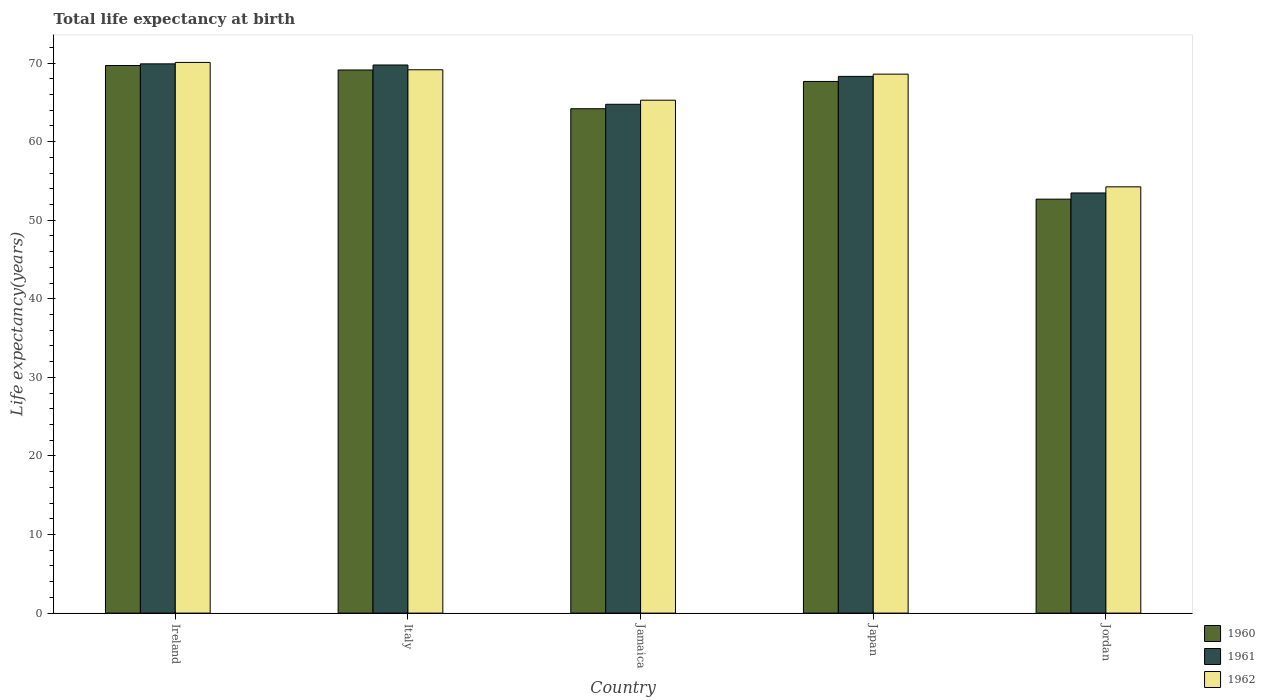How many bars are there on the 2nd tick from the left?
Your answer should be compact. 3. What is the label of the 3rd group of bars from the left?
Make the answer very short. Jamaica. In how many cases, is the number of bars for a given country not equal to the number of legend labels?
Your response must be concise. 0. What is the life expectancy at birth in in 1962 in Ireland?
Provide a succinct answer. 70.09. Across all countries, what is the maximum life expectancy at birth in in 1962?
Your response must be concise. 70.09. Across all countries, what is the minimum life expectancy at birth in in 1961?
Your answer should be compact. 53.47. In which country was the life expectancy at birth in in 1962 maximum?
Provide a short and direct response. Ireland. In which country was the life expectancy at birth in in 1961 minimum?
Provide a succinct answer. Jordan. What is the total life expectancy at birth in in 1960 in the graph?
Make the answer very short. 323.36. What is the difference between the life expectancy at birth in in 1960 in Ireland and that in Jordan?
Your answer should be compact. 17.01. What is the difference between the life expectancy at birth in in 1962 in Japan and the life expectancy at birth in in 1960 in Italy?
Ensure brevity in your answer.  -0.53. What is the average life expectancy at birth in in 1960 per country?
Provide a succinct answer. 64.67. What is the difference between the life expectancy at birth in of/in 1961 and life expectancy at birth in of/in 1960 in Jamaica?
Your answer should be compact. 0.57. In how many countries, is the life expectancy at birth in in 1961 greater than 62 years?
Offer a terse response. 4. What is the ratio of the life expectancy at birth in in 1962 in Jamaica to that in Jordan?
Your answer should be very brief. 1.2. Is the difference between the life expectancy at birth in in 1961 in Ireland and Japan greater than the difference between the life expectancy at birth in in 1960 in Ireland and Japan?
Offer a terse response. No. What is the difference between the highest and the second highest life expectancy at birth in in 1961?
Give a very brief answer. -0.14. What is the difference between the highest and the lowest life expectancy at birth in in 1960?
Offer a terse response. 17.01. In how many countries, is the life expectancy at birth in in 1962 greater than the average life expectancy at birth in in 1962 taken over all countries?
Offer a very short reply. 3. What does the 3rd bar from the right in Jamaica represents?
Ensure brevity in your answer.  1960. Are all the bars in the graph horizontal?
Keep it short and to the point. No. What is the difference between two consecutive major ticks on the Y-axis?
Provide a succinct answer. 10. Where does the legend appear in the graph?
Your answer should be very brief. Bottom right. How many legend labels are there?
Provide a short and direct response. 3. What is the title of the graph?
Make the answer very short. Total life expectancy at birth. What is the label or title of the X-axis?
Ensure brevity in your answer.  Country. What is the label or title of the Y-axis?
Provide a succinct answer. Life expectancy(years). What is the Life expectancy(years) of 1960 in Ireland?
Make the answer very short. 69.69. What is the Life expectancy(years) of 1961 in Ireland?
Your answer should be very brief. 69.9. What is the Life expectancy(years) of 1962 in Ireland?
Offer a terse response. 70.09. What is the Life expectancy(years) of 1960 in Italy?
Make the answer very short. 69.12. What is the Life expectancy(years) in 1961 in Italy?
Provide a short and direct response. 69.76. What is the Life expectancy(years) in 1962 in Italy?
Make the answer very short. 69.15. What is the Life expectancy(years) of 1960 in Jamaica?
Your response must be concise. 64.19. What is the Life expectancy(years) of 1961 in Jamaica?
Your answer should be very brief. 64.76. What is the Life expectancy(years) of 1962 in Jamaica?
Ensure brevity in your answer.  65.28. What is the Life expectancy(years) of 1960 in Japan?
Provide a short and direct response. 67.67. What is the Life expectancy(years) in 1961 in Japan?
Offer a very short reply. 68.31. What is the Life expectancy(years) of 1962 in Japan?
Your answer should be compact. 68.59. What is the Life expectancy(years) in 1960 in Jordan?
Provide a succinct answer. 52.69. What is the Life expectancy(years) in 1961 in Jordan?
Your answer should be very brief. 53.47. What is the Life expectancy(years) of 1962 in Jordan?
Your answer should be compact. 54.25. Across all countries, what is the maximum Life expectancy(years) in 1960?
Keep it short and to the point. 69.69. Across all countries, what is the maximum Life expectancy(years) in 1961?
Offer a very short reply. 69.9. Across all countries, what is the maximum Life expectancy(years) of 1962?
Keep it short and to the point. 70.09. Across all countries, what is the minimum Life expectancy(years) in 1960?
Give a very brief answer. 52.69. Across all countries, what is the minimum Life expectancy(years) of 1961?
Your answer should be compact. 53.47. Across all countries, what is the minimum Life expectancy(years) of 1962?
Make the answer very short. 54.25. What is the total Life expectancy(years) in 1960 in the graph?
Offer a terse response. 323.36. What is the total Life expectancy(years) in 1961 in the graph?
Provide a short and direct response. 326.21. What is the total Life expectancy(years) in 1962 in the graph?
Your answer should be compact. 327.36. What is the difference between the Life expectancy(years) in 1960 in Ireland and that in Italy?
Provide a succinct answer. 0.57. What is the difference between the Life expectancy(years) in 1961 in Ireland and that in Italy?
Your answer should be very brief. 0.14. What is the difference between the Life expectancy(years) of 1962 in Ireland and that in Italy?
Ensure brevity in your answer.  0.94. What is the difference between the Life expectancy(years) of 1960 in Ireland and that in Jamaica?
Your answer should be compact. 5.5. What is the difference between the Life expectancy(years) in 1961 in Ireland and that in Jamaica?
Make the answer very short. 5.14. What is the difference between the Life expectancy(years) in 1962 in Ireland and that in Jamaica?
Your response must be concise. 4.81. What is the difference between the Life expectancy(years) of 1960 in Ireland and that in Japan?
Provide a succinct answer. 2.03. What is the difference between the Life expectancy(years) of 1961 in Ireland and that in Japan?
Offer a very short reply. 1.59. What is the difference between the Life expectancy(years) of 1962 in Ireland and that in Japan?
Keep it short and to the point. 1.49. What is the difference between the Life expectancy(years) of 1960 in Ireland and that in Jordan?
Your response must be concise. 17.01. What is the difference between the Life expectancy(years) of 1961 in Ireland and that in Jordan?
Your answer should be compact. 16.43. What is the difference between the Life expectancy(years) of 1962 in Ireland and that in Jordan?
Offer a very short reply. 15.84. What is the difference between the Life expectancy(years) of 1960 in Italy and that in Jamaica?
Keep it short and to the point. 4.93. What is the difference between the Life expectancy(years) in 1961 in Italy and that in Jamaica?
Provide a short and direct response. 5. What is the difference between the Life expectancy(years) in 1962 in Italy and that in Jamaica?
Keep it short and to the point. 3.87. What is the difference between the Life expectancy(years) of 1960 in Italy and that in Japan?
Offer a terse response. 1.46. What is the difference between the Life expectancy(years) of 1961 in Italy and that in Japan?
Offer a terse response. 1.45. What is the difference between the Life expectancy(years) of 1962 in Italy and that in Japan?
Your response must be concise. 0.55. What is the difference between the Life expectancy(years) in 1960 in Italy and that in Jordan?
Keep it short and to the point. 16.44. What is the difference between the Life expectancy(years) in 1961 in Italy and that in Jordan?
Ensure brevity in your answer.  16.29. What is the difference between the Life expectancy(years) in 1962 in Italy and that in Jordan?
Your response must be concise. 14.9. What is the difference between the Life expectancy(years) in 1960 in Jamaica and that in Japan?
Offer a terse response. -3.47. What is the difference between the Life expectancy(years) in 1961 in Jamaica and that in Japan?
Ensure brevity in your answer.  -3.55. What is the difference between the Life expectancy(years) of 1962 in Jamaica and that in Japan?
Offer a very short reply. -3.32. What is the difference between the Life expectancy(years) of 1960 in Jamaica and that in Jordan?
Your answer should be very brief. 11.51. What is the difference between the Life expectancy(years) of 1961 in Jamaica and that in Jordan?
Keep it short and to the point. 11.29. What is the difference between the Life expectancy(years) of 1962 in Jamaica and that in Jordan?
Give a very brief answer. 11.03. What is the difference between the Life expectancy(years) of 1960 in Japan and that in Jordan?
Provide a short and direct response. 14.98. What is the difference between the Life expectancy(years) of 1961 in Japan and that in Jordan?
Provide a succinct answer. 14.84. What is the difference between the Life expectancy(years) of 1962 in Japan and that in Jordan?
Offer a terse response. 14.34. What is the difference between the Life expectancy(years) in 1960 in Ireland and the Life expectancy(years) in 1961 in Italy?
Make the answer very short. -0.07. What is the difference between the Life expectancy(years) of 1960 in Ireland and the Life expectancy(years) of 1962 in Italy?
Your response must be concise. 0.54. What is the difference between the Life expectancy(years) in 1961 in Ireland and the Life expectancy(years) in 1962 in Italy?
Give a very brief answer. 0.75. What is the difference between the Life expectancy(years) in 1960 in Ireland and the Life expectancy(years) in 1961 in Jamaica?
Provide a succinct answer. 4.93. What is the difference between the Life expectancy(years) in 1960 in Ireland and the Life expectancy(years) in 1962 in Jamaica?
Your answer should be very brief. 4.41. What is the difference between the Life expectancy(years) in 1961 in Ireland and the Life expectancy(years) in 1962 in Jamaica?
Provide a short and direct response. 4.62. What is the difference between the Life expectancy(years) in 1960 in Ireland and the Life expectancy(years) in 1961 in Japan?
Offer a terse response. 1.38. What is the difference between the Life expectancy(years) of 1960 in Ireland and the Life expectancy(years) of 1962 in Japan?
Provide a short and direct response. 1.1. What is the difference between the Life expectancy(years) in 1961 in Ireland and the Life expectancy(years) in 1962 in Japan?
Provide a short and direct response. 1.31. What is the difference between the Life expectancy(years) of 1960 in Ireland and the Life expectancy(years) of 1961 in Jordan?
Provide a succinct answer. 16.22. What is the difference between the Life expectancy(years) of 1960 in Ireland and the Life expectancy(years) of 1962 in Jordan?
Your answer should be compact. 15.44. What is the difference between the Life expectancy(years) of 1961 in Ireland and the Life expectancy(years) of 1962 in Jordan?
Provide a succinct answer. 15.65. What is the difference between the Life expectancy(years) of 1960 in Italy and the Life expectancy(years) of 1961 in Jamaica?
Offer a very short reply. 4.36. What is the difference between the Life expectancy(years) in 1960 in Italy and the Life expectancy(years) in 1962 in Jamaica?
Your answer should be compact. 3.84. What is the difference between the Life expectancy(years) of 1961 in Italy and the Life expectancy(years) of 1962 in Jamaica?
Give a very brief answer. 4.48. What is the difference between the Life expectancy(years) in 1960 in Italy and the Life expectancy(years) in 1961 in Japan?
Offer a very short reply. 0.81. What is the difference between the Life expectancy(years) in 1960 in Italy and the Life expectancy(years) in 1962 in Japan?
Offer a very short reply. 0.53. What is the difference between the Life expectancy(years) in 1961 in Italy and the Life expectancy(years) in 1962 in Japan?
Offer a very short reply. 1.17. What is the difference between the Life expectancy(years) in 1960 in Italy and the Life expectancy(years) in 1961 in Jordan?
Offer a very short reply. 15.65. What is the difference between the Life expectancy(years) in 1960 in Italy and the Life expectancy(years) in 1962 in Jordan?
Your response must be concise. 14.87. What is the difference between the Life expectancy(years) of 1961 in Italy and the Life expectancy(years) of 1962 in Jordan?
Provide a succinct answer. 15.51. What is the difference between the Life expectancy(years) of 1960 in Jamaica and the Life expectancy(years) of 1961 in Japan?
Make the answer very short. -4.12. What is the difference between the Life expectancy(years) in 1960 in Jamaica and the Life expectancy(years) in 1962 in Japan?
Your answer should be very brief. -4.4. What is the difference between the Life expectancy(years) in 1961 in Jamaica and the Life expectancy(years) in 1962 in Japan?
Your response must be concise. -3.84. What is the difference between the Life expectancy(years) of 1960 in Jamaica and the Life expectancy(years) of 1961 in Jordan?
Provide a short and direct response. 10.72. What is the difference between the Life expectancy(years) in 1960 in Jamaica and the Life expectancy(years) in 1962 in Jordan?
Provide a succinct answer. 9.94. What is the difference between the Life expectancy(years) in 1961 in Jamaica and the Life expectancy(years) in 1962 in Jordan?
Offer a terse response. 10.51. What is the difference between the Life expectancy(years) in 1960 in Japan and the Life expectancy(years) in 1961 in Jordan?
Your answer should be very brief. 14.19. What is the difference between the Life expectancy(years) of 1960 in Japan and the Life expectancy(years) of 1962 in Jordan?
Give a very brief answer. 13.41. What is the difference between the Life expectancy(years) in 1961 in Japan and the Life expectancy(years) in 1962 in Jordan?
Offer a terse response. 14.06. What is the average Life expectancy(years) in 1960 per country?
Provide a succinct answer. 64.67. What is the average Life expectancy(years) of 1961 per country?
Offer a very short reply. 65.24. What is the average Life expectancy(years) of 1962 per country?
Keep it short and to the point. 65.47. What is the difference between the Life expectancy(years) in 1960 and Life expectancy(years) in 1961 in Ireland?
Provide a short and direct response. -0.21. What is the difference between the Life expectancy(years) in 1960 and Life expectancy(years) in 1962 in Ireland?
Your response must be concise. -0.4. What is the difference between the Life expectancy(years) in 1961 and Life expectancy(years) in 1962 in Ireland?
Keep it short and to the point. -0.18. What is the difference between the Life expectancy(years) in 1960 and Life expectancy(years) in 1961 in Italy?
Offer a very short reply. -0.64. What is the difference between the Life expectancy(years) of 1960 and Life expectancy(years) of 1962 in Italy?
Provide a succinct answer. -0.03. What is the difference between the Life expectancy(years) in 1961 and Life expectancy(years) in 1962 in Italy?
Offer a terse response. 0.61. What is the difference between the Life expectancy(years) in 1960 and Life expectancy(years) in 1961 in Jamaica?
Your response must be concise. -0.57. What is the difference between the Life expectancy(years) of 1960 and Life expectancy(years) of 1962 in Jamaica?
Your answer should be compact. -1.09. What is the difference between the Life expectancy(years) of 1961 and Life expectancy(years) of 1962 in Jamaica?
Your answer should be compact. -0.52. What is the difference between the Life expectancy(years) of 1960 and Life expectancy(years) of 1961 in Japan?
Make the answer very short. -0.64. What is the difference between the Life expectancy(years) of 1960 and Life expectancy(years) of 1962 in Japan?
Your answer should be very brief. -0.93. What is the difference between the Life expectancy(years) in 1961 and Life expectancy(years) in 1962 in Japan?
Give a very brief answer. -0.28. What is the difference between the Life expectancy(years) of 1960 and Life expectancy(years) of 1961 in Jordan?
Offer a terse response. -0.79. What is the difference between the Life expectancy(years) in 1960 and Life expectancy(years) in 1962 in Jordan?
Make the answer very short. -1.57. What is the difference between the Life expectancy(years) in 1961 and Life expectancy(years) in 1962 in Jordan?
Give a very brief answer. -0.78. What is the ratio of the Life expectancy(years) of 1960 in Ireland to that in Italy?
Your answer should be very brief. 1.01. What is the ratio of the Life expectancy(years) of 1962 in Ireland to that in Italy?
Your response must be concise. 1.01. What is the ratio of the Life expectancy(years) of 1960 in Ireland to that in Jamaica?
Keep it short and to the point. 1.09. What is the ratio of the Life expectancy(years) of 1961 in Ireland to that in Jamaica?
Provide a succinct answer. 1.08. What is the ratio of the Life expectancy(years) of 1962 in Ireland to that in Jamaica?
Offer a terse response. 1.07. What is the ratio of the Life expectancy(years) in 1960 in Ireland to that in Japan?
Provide a succinct answer. 1.03. What is the ratio of the Life expectancy(years) of 1961 in Ireland to that in Japan?
Offer a terse response. 1.02. What is the ratio of the Life expectancy(years) of 1962 in Ireland to that in Japan?
Offer a very short reply. 1.02. What is the ratio of the Life expectancy(years) in 1960 in Ireland to that in Jordan?
Make the answer very short. 1.32. What is the ratio of the Life expectancy(years) in 1961 in Ireland to that in Jordan?
Make the answer very short. 1.31. What is the ratio of the Life expectancy(years) of 1962 in Ireland to that in Jordan?
Offer a very short reply. 1.29. What is the ratio of the Life expectancy(years) in 1960 in Italy to that in Jamaica?
Provide a succinct answer. 1.08. What is the ratio of the Life expectancy(years) in 1961 in Italy to that in Jamaica?
Provide a short and direct response. 1.08. What is the ratio of the Life expectancy(years) in 1962 in Italy to that in Jamaica?
Ensure brevity in your answer.  1.06. What is the ratio of the Life expectancy(years) in 1960 in Italy to that in Japan?
Give a very brief answer. 1.02. What is the ratio of the Life expectancy(years) of 1961 in Italy to that in Japan?
Your answer should be very brief. 1.02. What is the ratio of the Life expectancy(years) of 1960 in Italy to that in Jordan?
Ensure brevity in your answer.  1.31. What is the ratio of the Life expectancy(years) in 1961 in Italy to that in Jordan?
Ensure brevity in your answer.  1.3. What is the ratio of the Life expectancy(years) of 1962 in Italy to that in Jordan?
Your response must be concise. 1.27. What is the ratio of the Life expectancy(years) of 1960 in Jamaica to that in Japan?
Make the answer very short. 0.95. What is the ratio of the Life expectancy(years) of 1961 in Jamaica to that in Japan?
Make the answer very short. 0.95. What is the ratio of the Life expectancy(years) of 1962 in Jamaica to that in Japan?
Keep it short and to the point. 0.95. What is the ratio of the Life expectancy(years) of 1960 in Jamaica to that in Jordan?
Keep it short and to the point. 1.22. What is the ratio of the Life expectancy(years) in 1961 in Jamaica to that in Jordan?
Provide a short and direct response. 1.21. What is the ratio of the Life expectancy(years) of 1962 in Jamaica to that in Jordan?
Ensure brevity in your answer.  1.2. What is the ratio of the Life expectancy(years) of 1960 in Japan to that in Jordan?
Keep it short and to the point. 1.28. What is the ratio of the Life expectancy(years) in 1961 in Japan to that in Jordan?
Your answer should be very brief. 1.28. What is the ratio of the Life expectancy(years) of 1962 in Japan to that in Jordan?
Your answer should be very brief. 1.26. What is the difference between the highest and the second highest Life expectancy(years) in 1960?
Your answer should be compact. 0.57. What is the difference between the highest and the second highest Life expectancy(years) of 1961?
Offer a terse response. 0.14. What is the difference between the highest and the second highest Life expectancy(years) in 1962?
Make the answer very short. 0.94. What is the difference between the highest and the lowest Life expectancy(years) of 1960?
Your answer should be very brief. 17.01. What is the difference between the highest and the lowest Life expectancy(years) in 1961?
Give a very brief answer. 16.43. What is the difference between the highest and the lowest Life expectancy(years) in 1962?
Your response must be concise. 15.84. 